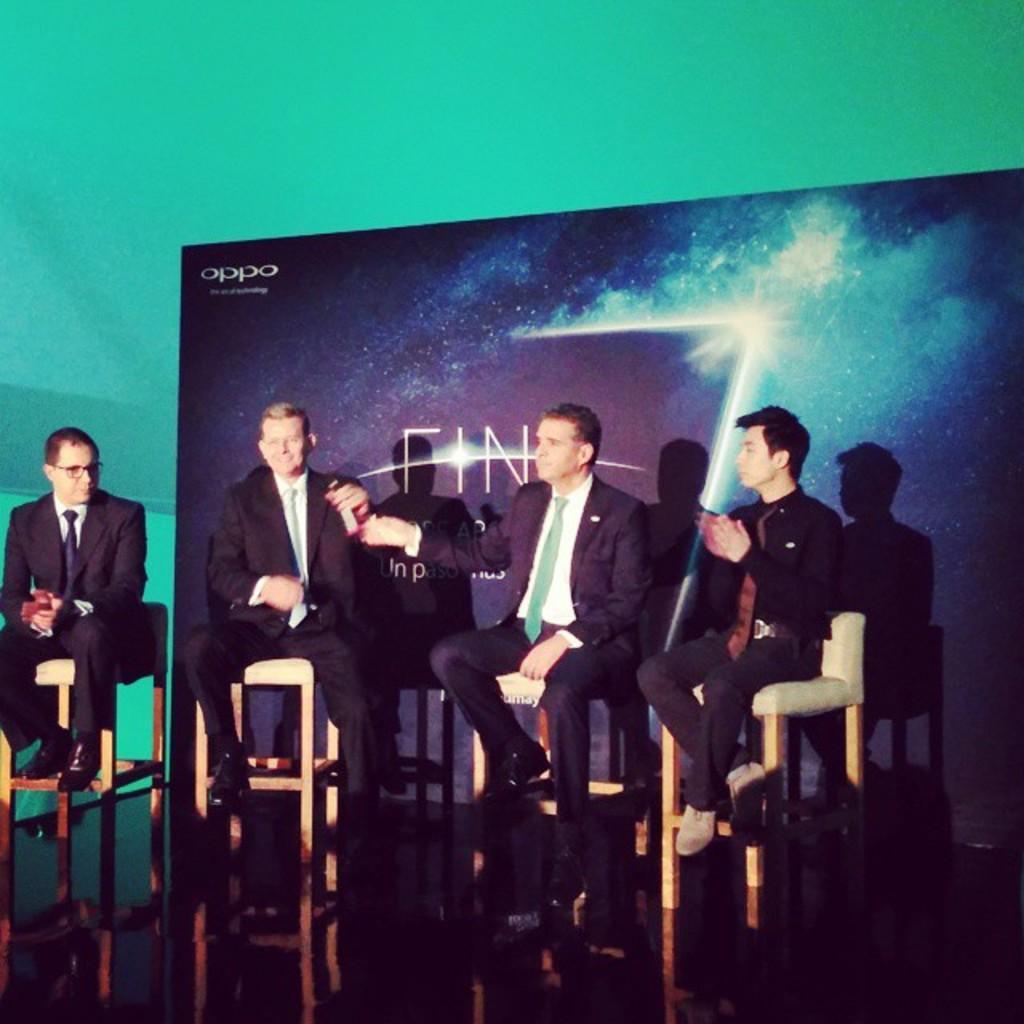Describe this image in one or two sentences. In this image there are four men sitting in the chairs. In the background there is a banner. Behind the banner there is a green color background. The man on the right side is clapping. 